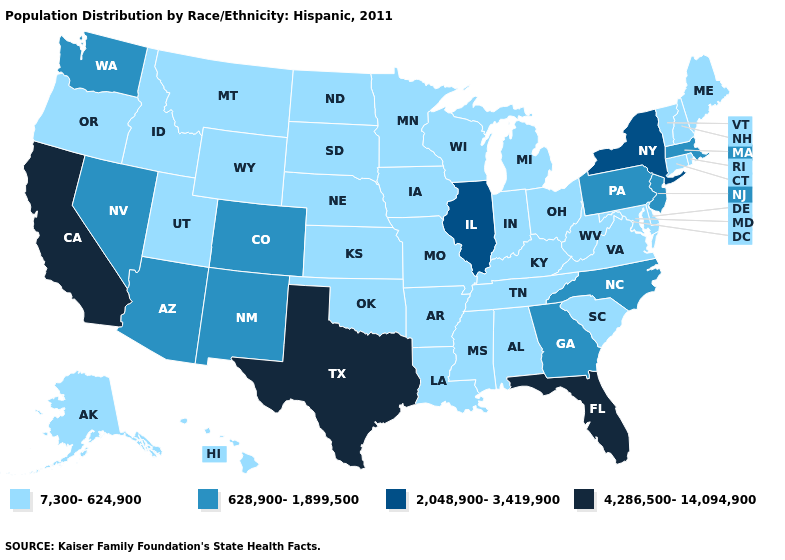Does Connecticut have the lowest value in the USA?
Quick response, please. Yes. Does Oregon have the same value as Massachusetts?
Short answer required. No. What is the highest value in the USA?
Keep it brief. 4,286,500-14,094,900. Is the legend a continuous bar?
Quick response, please. No. Among the states that border Connecticut , does Rhode Island have the highest value?
Write a very short answer. No. Among the states that border Ohio , does Pennsylvania have the lowest value?
Quick response, please. No. Does Rhode Island have the lowest value in the Northeast?
Answer briefly. Yes. Does the map have missing data?
Answer briefly. No. What is the value of Florida?
Quick response, please. 4,286,500-14,094,900. Does New York have the highest value in the Northeast?
Short answer required. Yes. How many symbols are there in the legend?
Write a very short answer. 4. Name the states that have a value in the range 7,300-624,900?
Write a very short answer. Alabama, Alaska, Arkansas, Connecticut, Delaware, Hawaii, Idaho, Indiana, Iowa, Kansas, Kentucky, Louisiana, Maine, Maryland, Michigan, Minnesota, Mississippi, Missouri, Montana, Nebraska, New Hampshire, North Dakota, Ohio, Oklahoma, Oregon, Rhode Island, South Carolina, South Dakota, Tennessee, Utah, Vermont, Virginia, West Virginia, Wisconsin, Wyoming. Which states have the lowest value in the South?
Be succinct. Alabama, Arkansas, Delaware, Kentucky, Louisiana, Maryland, Mississippi, Oklahoma, South Carolina, Tennessee, Virginia, West Virginia. Is the legend a continuous bar?
Be succinct. No. 